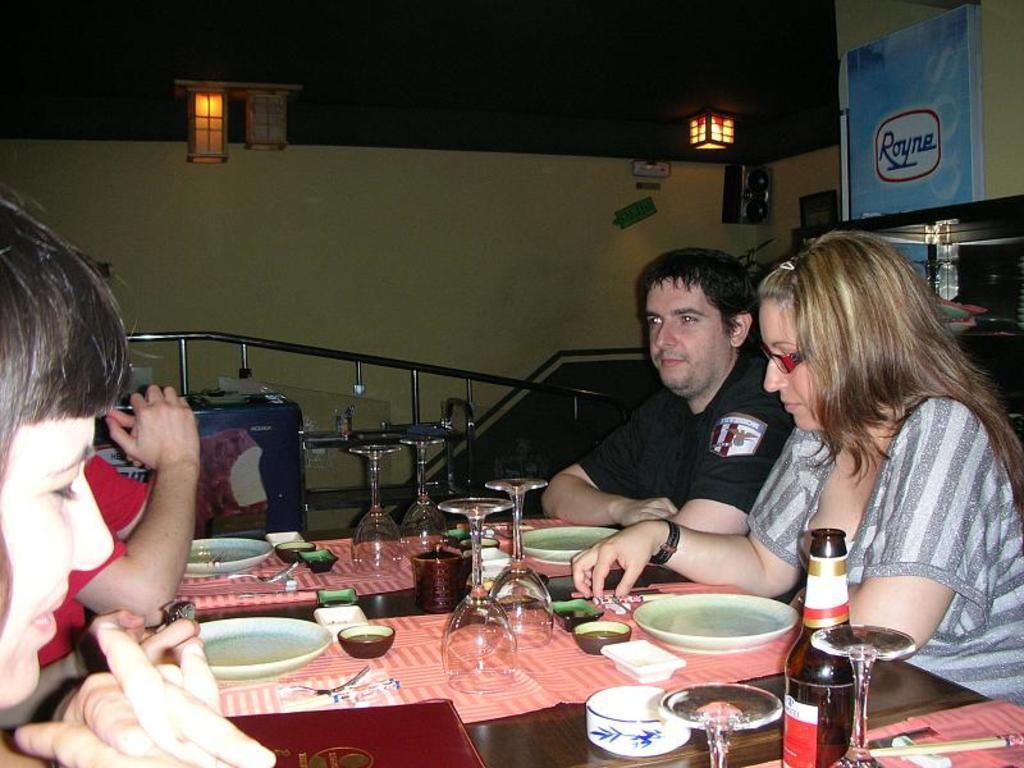How would you summarize this image in a sentence or two? Four person are sitting around a table. On the table there are mat, glasses, plates, bowls, menu card are there. In the background there is a wall. There are lights in the ceiling. 